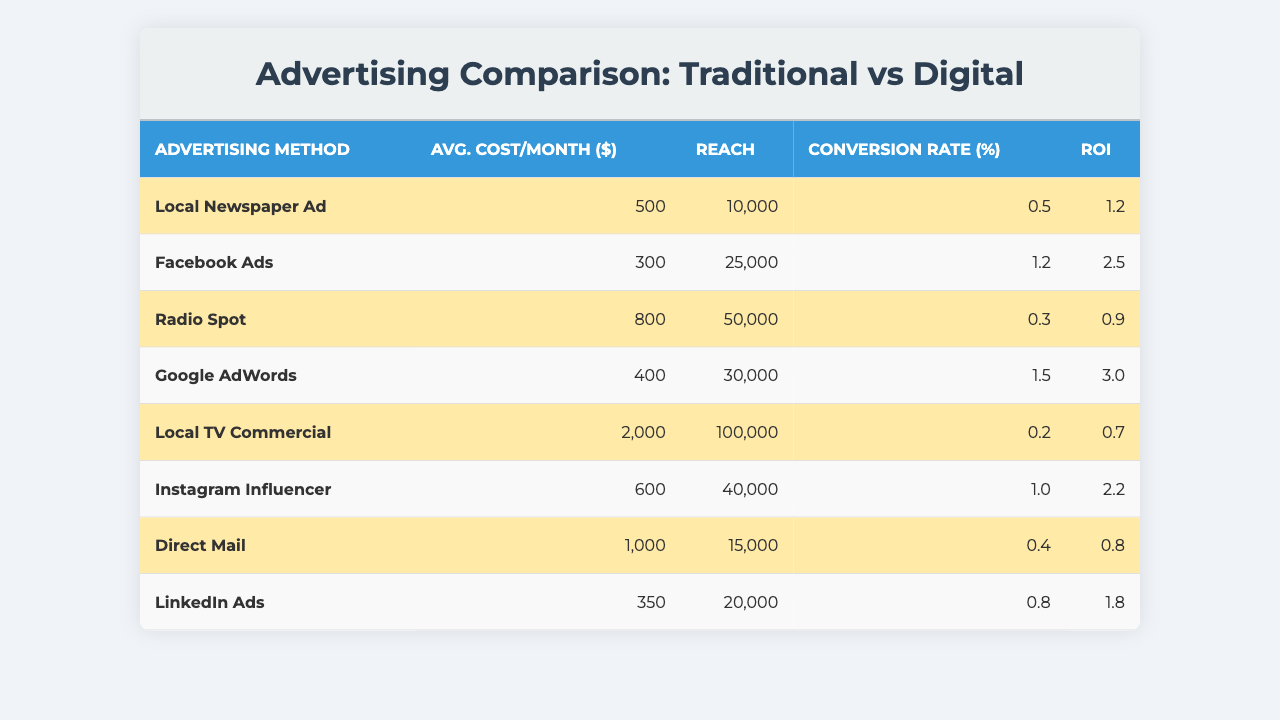What is the average cost per month for Facebook Ads? The average cost per month for Facebook Ads is listed directly in the table. It shows 300 dollars.
Answer: 300 What is the reach of the Local TV Commercial? The reach for the Local TV Commercial is explicitly stated in the table as 100,000.
Answer: 100000 Which advertising method has the highest ROI? To find the highest ROI, we need to compare the ROI values of all methods. Google AdWords has the highest ROI at 3.0.
Answer: Google AdWords Is the conversion rate for Radio Spot higher than that for Local Newspaper Ad? The conversion rates are listed: Radio Spot is at 0.3, and Local Newspaper Ad is at 0.5. Since 0.3 is less than 0.5, the statement is false.
Answer: No What is the total average cost per month for all traditional advertising methods? Adding the average costs for traditional methods: Local Newspaper Ad (500) + Radio Spot (800) + Local TV Commercial (2000) + Direct Mail (1000) = 4300. Thus, the total is 4300 dollars.
Answer: 4300 What percentage of advertising methods are classified as digital? There are 8 total advertising methods; 4 methods (Facebook Ads, Google AdWords, Instagram Influencer, and LinkedIn Ads) are classified as digital. The percentage is (4/8) * 100 = 50%.
Answer: 50% Which advertising method reaches the second most people? The reach ranking is: Local TV Commercial (100,000), Radio Spot (50,000), Instagram Influencer (40,000), and so on. Therefore, Radio Spot has the second highest reach.
Answer: Radio Spot What is the difference in average costs between the most expensive and the least expensive advertising methods? Local TV Commercial is the most expensive at 2000 dollars, and LinkedIn Ads is the least expensive at 350 dollars. The difference is 2000 - 350 = 1650 dollars.
Answer: 1650 If a business spends on average 500 dollars on advertising per month, which methods could potentially give a higher conversion rate? We first note methods with average costs under 500 dollars: Facebook Ads (300), Google AdWords (400), and LinkedIn Ads (350). Their conversion rates (1.2, 1.5, and 0.8 respectively) must be considered. Both Facebook Ads and Google AdWords offer higher conversion rates than 0.5.
Answer: Facebook Ads and Google AdWords What is the average ROI for digital advertising methods? Calculate the ROI for digital methods: Facebook Ads (2.5), Google AdWords (3.0), Instagram Influencer (2.2), and LinkedIn Ads (1.8). The sum is 2.5 + 3.0 + 2.2 + 1.8 = 9.5. Dividing by 4 gives an average of 2.375.
Answer: 2.375 